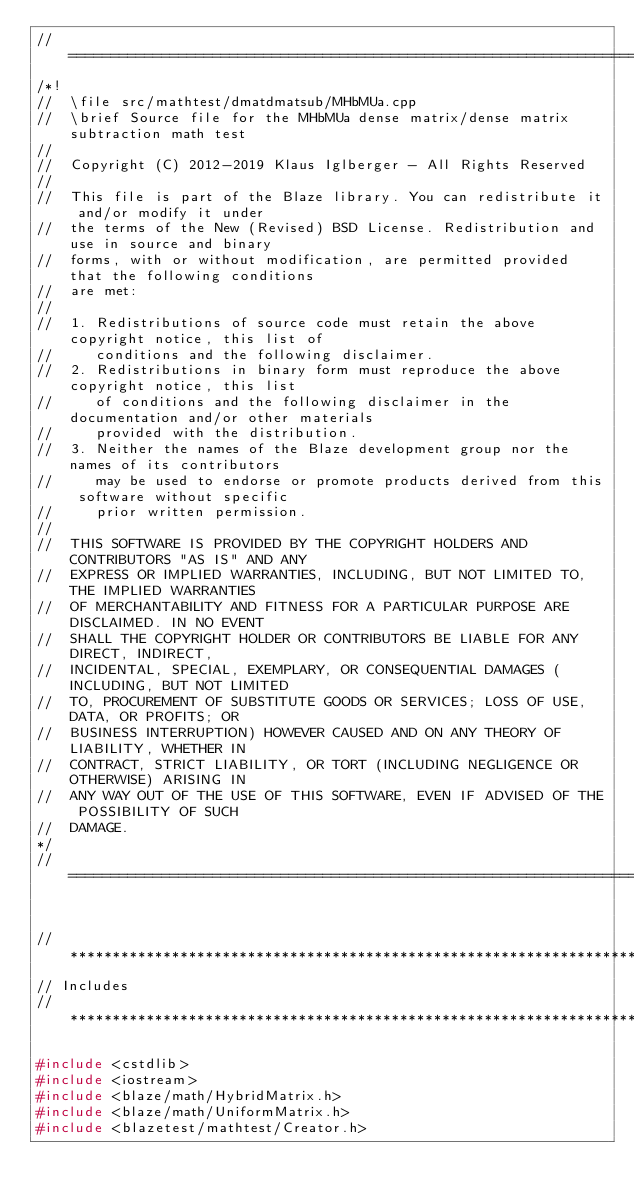<code> <loc_0><loc_0><loc_500><loc_500><_C++_>//=================================================================================================
/*!
//  \file src/mathtest/dmatdmatsub/MHbMUa.cpp
//  \brief Source file for the MHbMUa dense matrix/dense matrix subtraction math test
//
//  Copyright (C) 2012-2019 Klaus Iglberger - All Rights Reserved
//
//  This file is part of the Blaze library. You can redistribute it and/or modify it under
//  the terms of the New (Revised) BSD License. Redistribution and use in source and binary
//  forms, with or without modification, are permitted provided that the following conditions
//  are met:
//
//  1. Redistributions of source code must retain the above copyright notice, this list of
//     conditions and the following disclaimer.
//  2. Redistributions in binary form must reproduce the above copyright notice, this list
//     of conditions and the following disclaimer in the documentation and/or other materials
//     provided with the distribution.
//  3. Neither the names of the Blaze development group nor the names of its contributors
//     may be used to endorse or promote products derived from this software without specific
//     prior written permission.
//
//  THIS SOFTWARE IS PROVIDED BY THE COPYRIGHT HOLDERS AND CONTRIBUTORS "AS IS" AND ANY
//  EXPRESS OR IMPLIED WARRANTIES, INCLUDING, BUT NOT LIMITED TO, THE IMPLIED WARRANTIES
//  OF MERCHANTABILITY AND FITNESS FOR A PARTICULAR PURPOSE ARE DISCLAIMED. IN NO EVENT
//  SHALL THE COPYRIGHT HOLDER OR CONTRIBUTORS BE LIABLE FOR ANY DIRECT, INDIRECT,
//  INCIDENTAL, SPECIAL, EXEMPLARY, OR CONSEQUENTIAL DAMAGES (INCLUDING, BUT NOT LIMITED
//  TO, PROCUREMENT OF SUBSTITUTE GOODS OR SERVICES; LOSS OF USE, DATA, OR PROFITS; OR
//  BUSINESS INTERRUPTION) HOWEVER CAUSED AND ON ANY THEORY OF LIABILITY, WHETHER IN
//  CONTRACT, STRICT LIABILITY, OR TORT (INCLUDING NEGLIGENCE OR OTHERWISE) ARISING IN
//  ANY WAY OUT OF THE USE OF THIS SOFTWARE, EVEN IF ADVISED OF THE POSSIBILITY OF SUCH
//  DAMAGE.
*/
//=================================================================================================


//*************************************************************************************************
// Includes
//*************************************************************************************************

#include <cstdlib>
#include <iostream>
#include <blaze/math/HybridMatrix.h>
#include <blaze/math/UniformMatrix.h>
#include <blazetest/mathtest/Creator.h></code> 